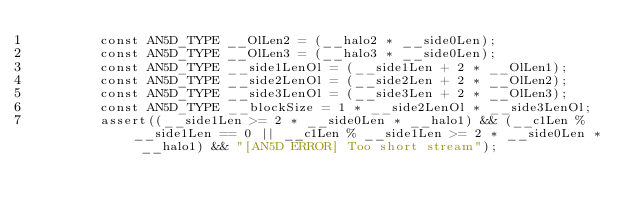Convert code to text. <code><loc_0><loc_0><loc_500><loc_500><_Cuda_>        const AN5D_TYPE __OlLen2 = (__halo2 * __side0Len);
        const AN5D_TYPE __OlLen3 = (__halo3 * __side0Len);
        const AN5D_TYPE __side1LenOl = (__side1Len + 2 * __OlLen1);
        const AN5D_TYPE __side2LenOl = (__side2Len + 2 * __OlLen2);
        const AN5D_TYPE __side3LenOl = (__side3Len + 2 * __OlLen3);
        const AN5D_TYPE __blockSize = 1 * __side2LenOl * __side3LenOl;
        assert((__side1Len >= 2 * __side0Len * __halo1) && (__c1Len % __side1Len == 0 || __c1Len % __side1Len >= 2 * __side0Len * __halo1) && "[AN5D ERROR] Too short stream");</code> 